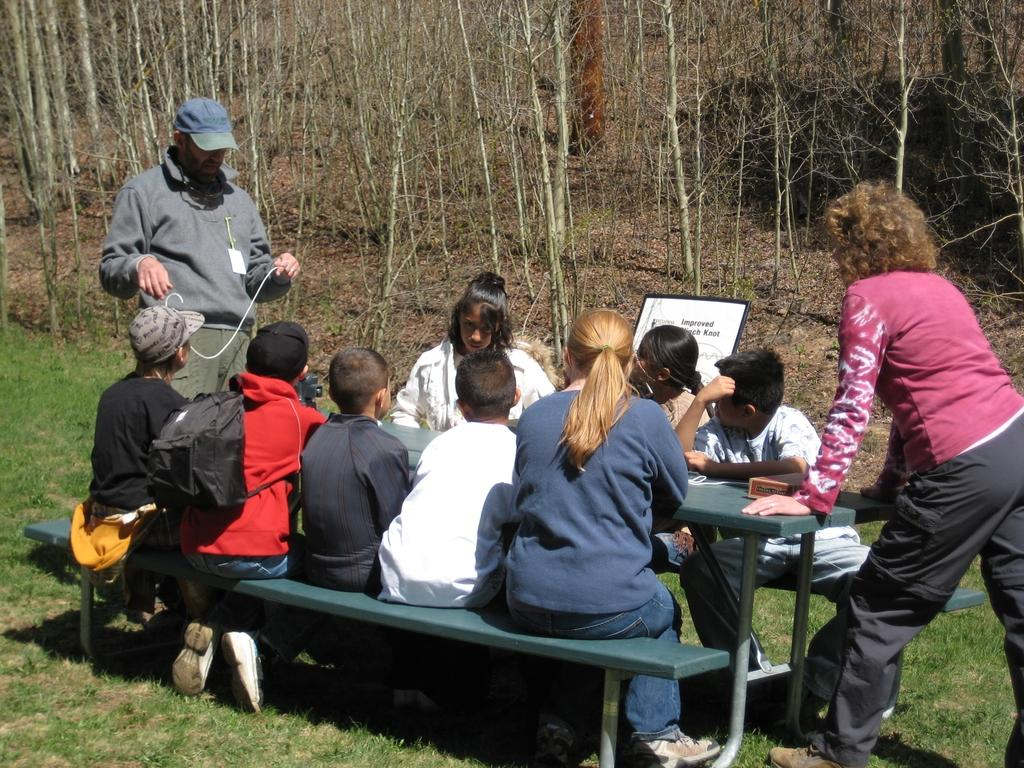Who are the people in the image? There are children, a lady, a man, and a woman in the image. What is the lady doing in the image? The lady is sitting on a bench in the image. Where is the bench located? The bench is on a grass field. What are the man and woman doing in the image? The man and woman are standing in the image. What can be seen beside the man and woman? There are trees beside the man and woman. What type of owl can be seen talking to the children in the image? There is no owl present in the image, and the children are not engaged in any conversation with an owl or any other animal. 